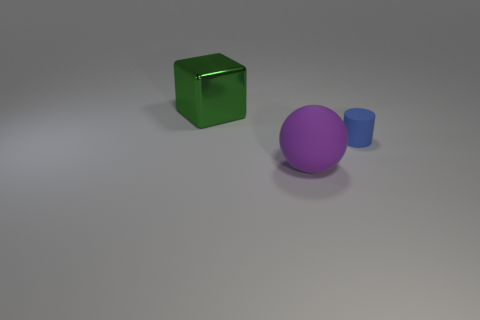How big is the rubber object on the left side of the blue matte thing?
Offer a very short reply. Large. There is a green thing that is the same size as the purple ball; what is its material?
Keep it short and to the point. Metal. Is the shape of the small blue rubber object the same as the metallic object?
Offer a very short reply. No. How many things are blue rubber cylinders or matte objects in front of the small thing?
Offer a very short reply. 2. There is a thing that is on the right side of the ball; is it the same size as the block?
Your answer should be very brief. No. There is a large object in front of the big thing that is behind the tiny blue rubber thing; what number of big green objects are behind it?
Offer a very short reply. 1. What number of blue things are either large blocks or tiny objects?
Your response must be concise. 1. The small thing that is the same material as the big purple thing is what color?
Provide a short and direct response. Blue. Is there any other thing that has the same size as the green object?
Your response must be concise. Yes. What number of large objects are purple rubber blocks or green metallic blocks?
Provide a succinct answer. 1. 